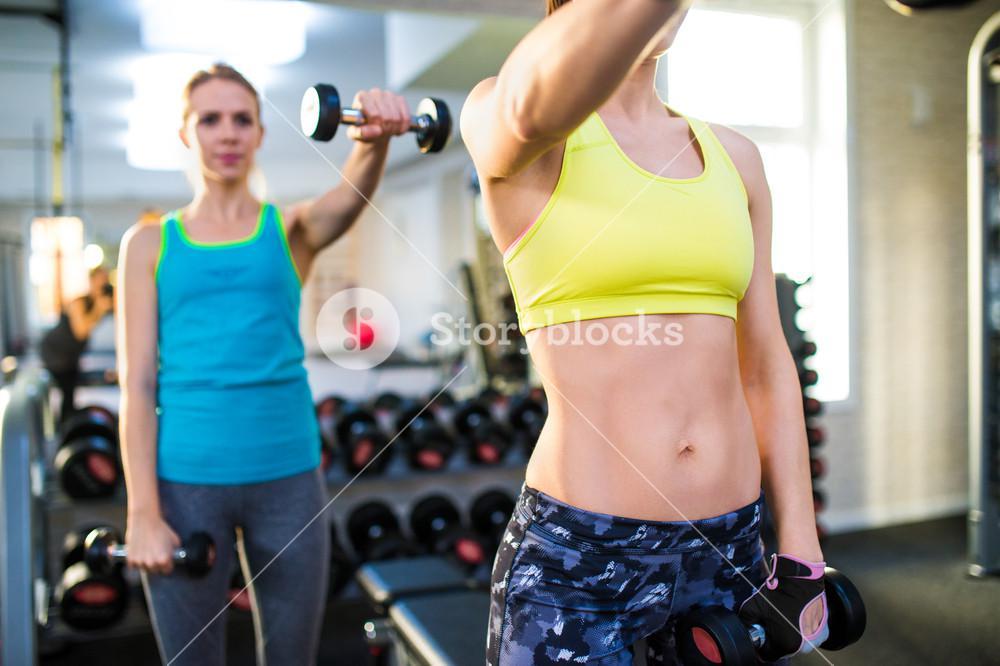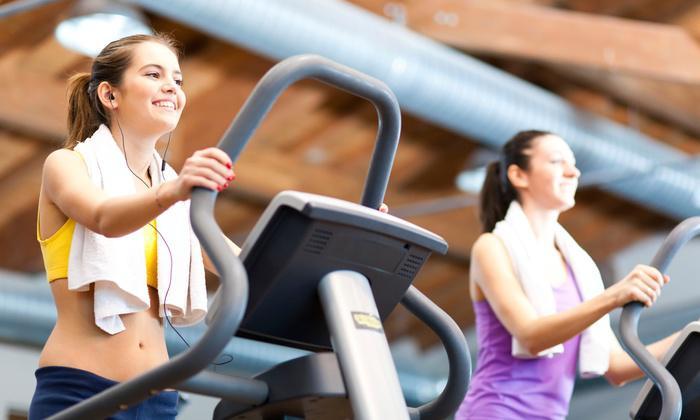The first image is the image on the left, the second image is the image on the right. Given the left and right images, does the statement "At least one of the images has a man." hold true? Answer yes or no. No. The first image is the image on the left, the second image is the image on the right. Considering the images on both sides, is "The left and right image contains  a total of four people working out." valid? Answer yes or no. Yes. 